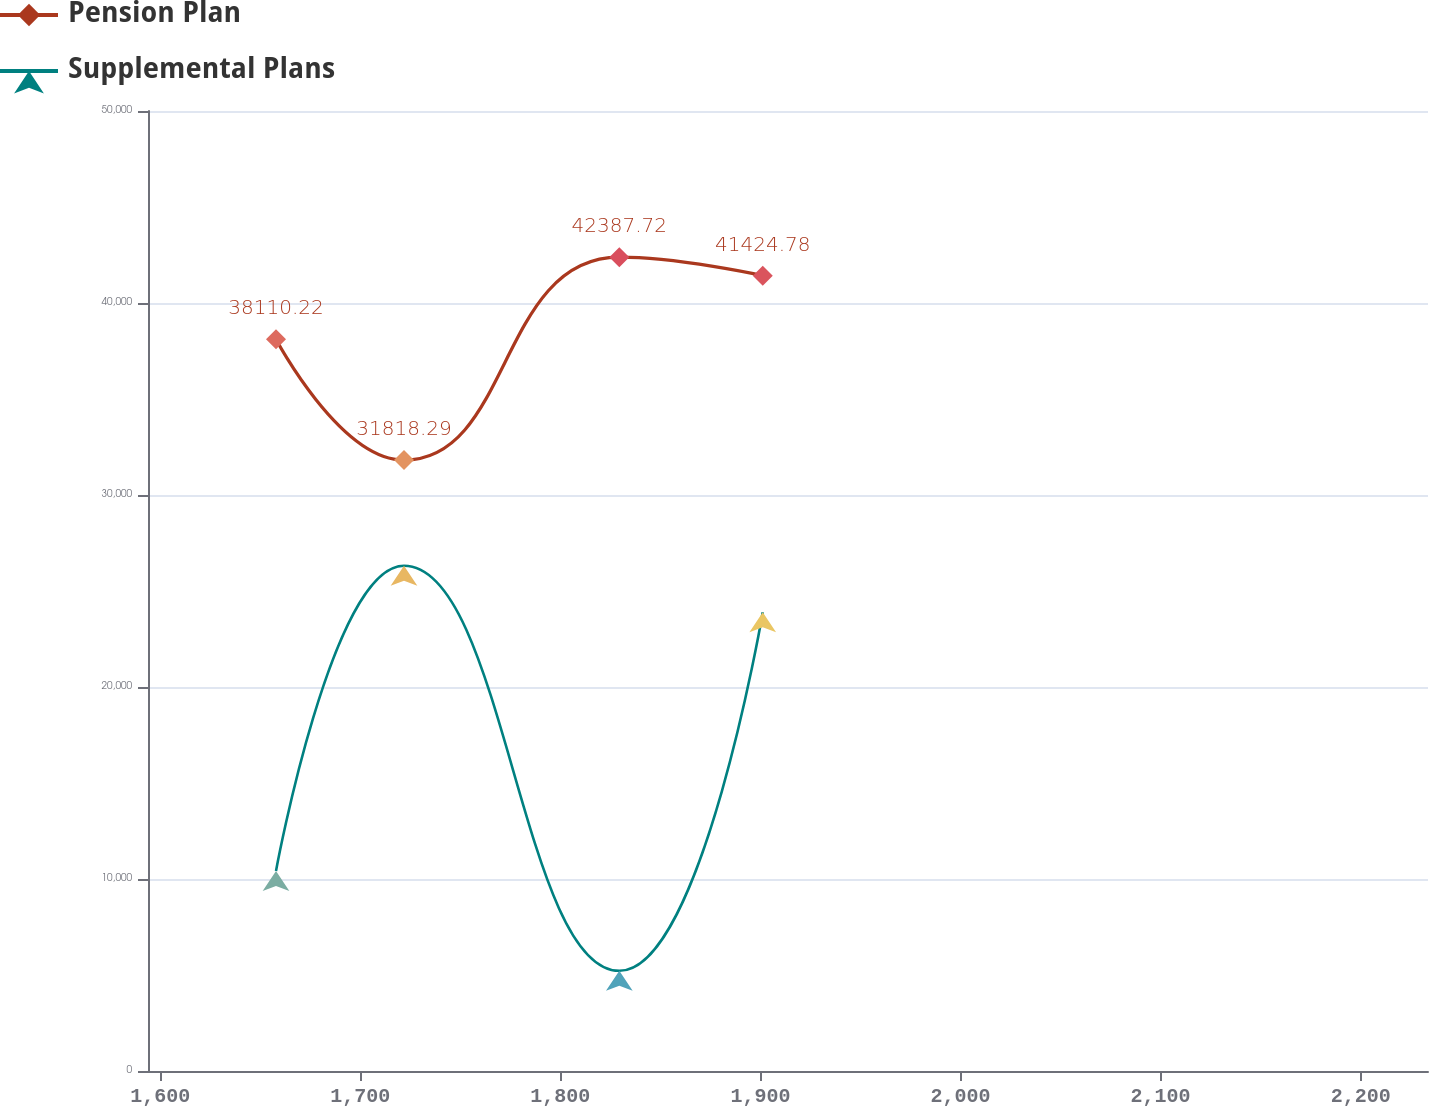<chart> <loc_0><loc_0><loc_500><loc_500><line_chart><ecel><fcel>Pension Plan<fcel>Supplemental Plans<nl><fcel>1657.9<fcel>38110.2<fcel>10419.3<nl><fcel>1721.87<fcel>31818.3<fcel>26316.9<nl><fcel>1829.49<fcel>42387.7<fcel>5218.74<nl><fcel>1901.17<fcel>41424.8<fcel>23891.3<nl><fcel>2297.63<fcel>39918.1<fcel>12529.1<nl></chart> 